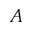<formula> <loc_0><loc_0><loc_500><loc_500>A</formula> 